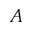<formula> <loc_0><loc_0><loc_500><loc_500>A</formula> 